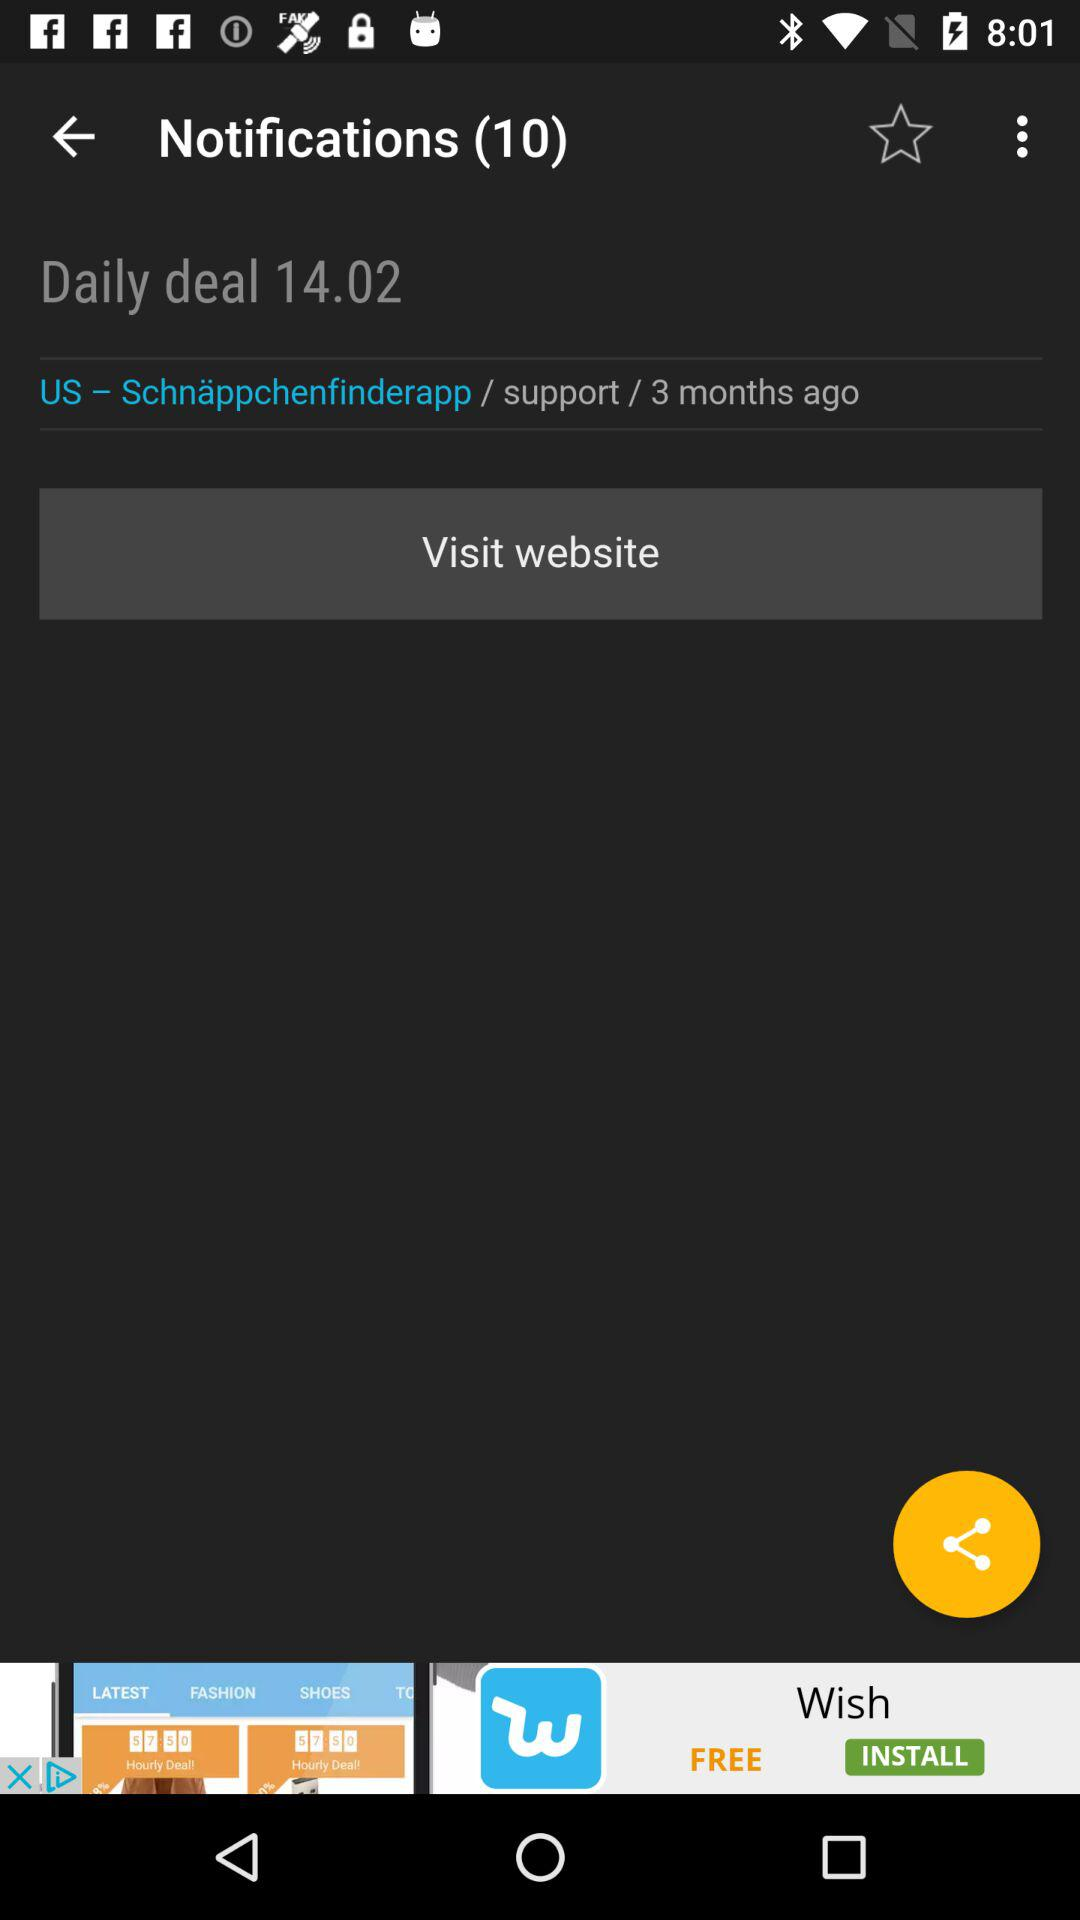How many months ago was the "Daily deal 14.02" updated? The "Daily deal 14.02" was updated 3 months ago. 